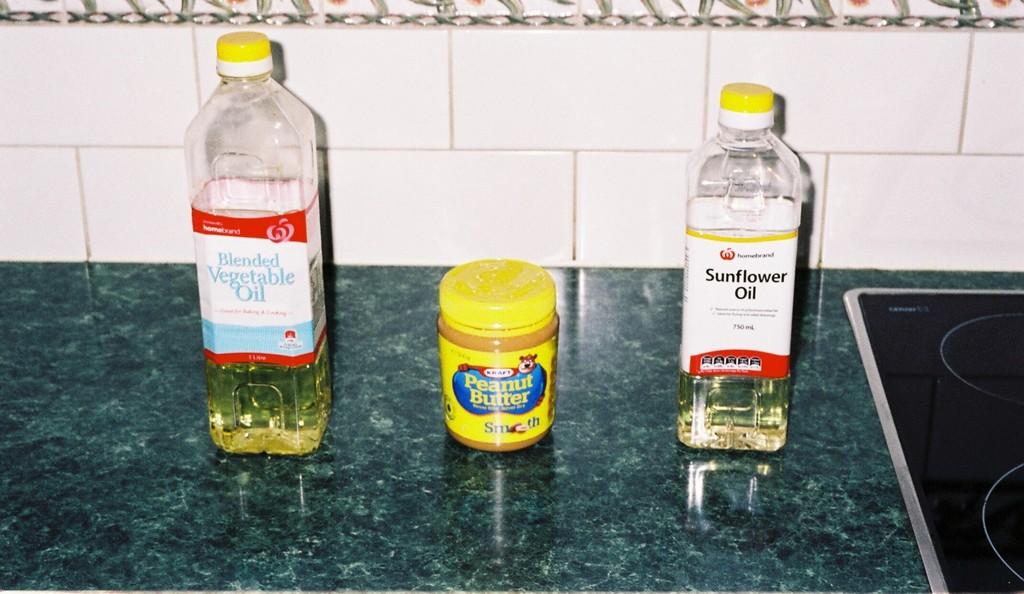Chat kind of oil is on the right?
Make the answer very short. Sunflower. What is in the middle jar?
Make the answer very short. Peanut butter. 